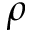<formula> <loc_0><loc_0><loc_500><loc_500>\rho</formula> 